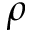<formula> <loc_0><loc_0><loc_500><loc_500>\rho</formula> 